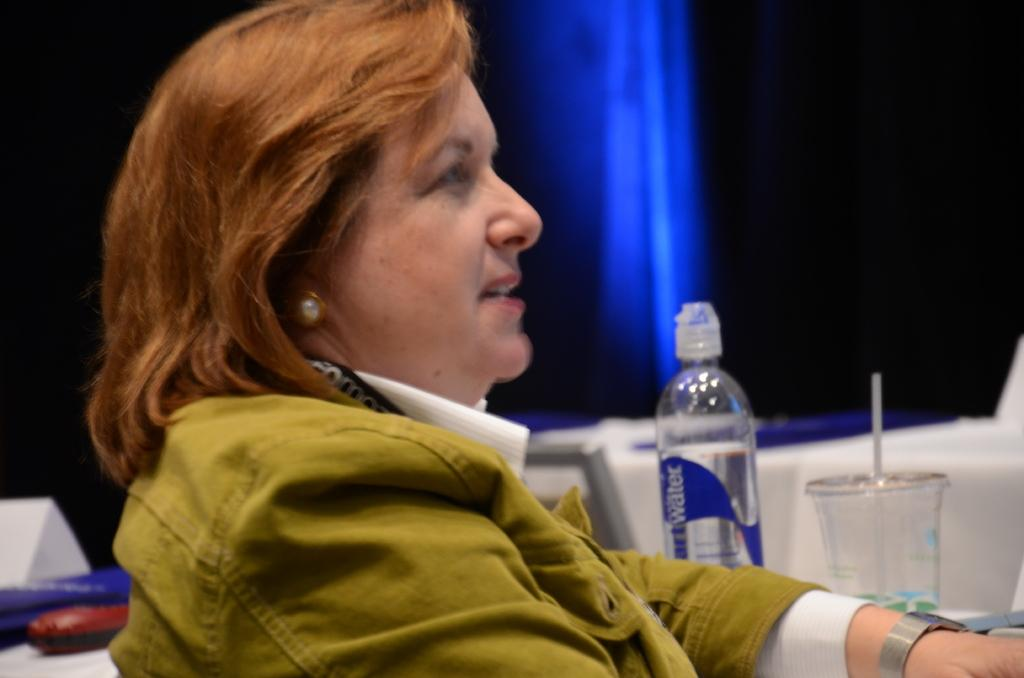What is the woman in the image doing? The woman is sitting in the image. What items are beside the woman? There is a water bottle and a plastic cup beside the woman. What type of grape can be seen in the woman's hand in the image? There is no grape present in the image; the woman is not holding any grapes. 